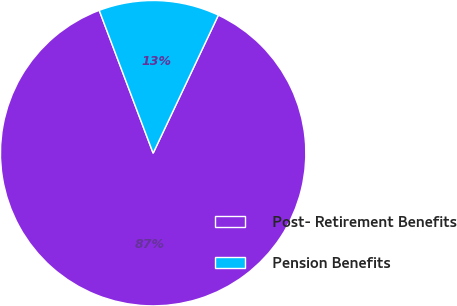Convert chart to OTSL. <chart><loc_0><loc_0><loc_500><loc_500><pie_chart><fcel>Post- Retirement Benefits<fcel>Pension Benefits<nl><fcel>87.23%<fcel>12.77%<nl></chart> 